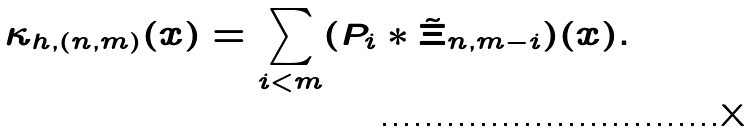<formula> <loc_0><loc_0><loc_500><loc_500>\kappa _ { h , ( n , m ) } ( x ) = \sum _ { i < m } ( P _ { i } * \tilde { \Xi } _ { n , m - i } ) ( x ) .</formula> 